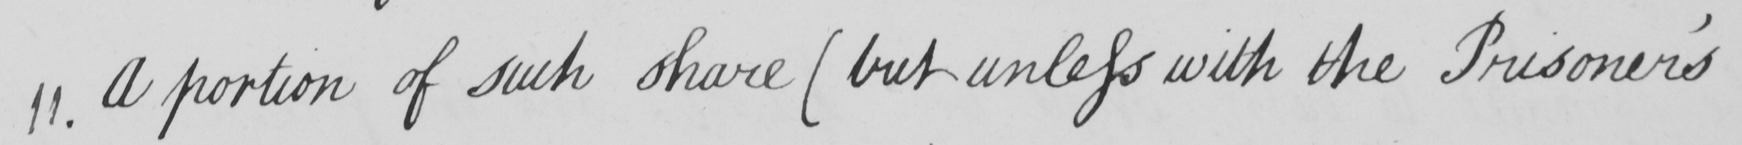Can you tell me what this handwritten text says? 11 . A portion of such share  ( but unless with the Prisoner ' s 